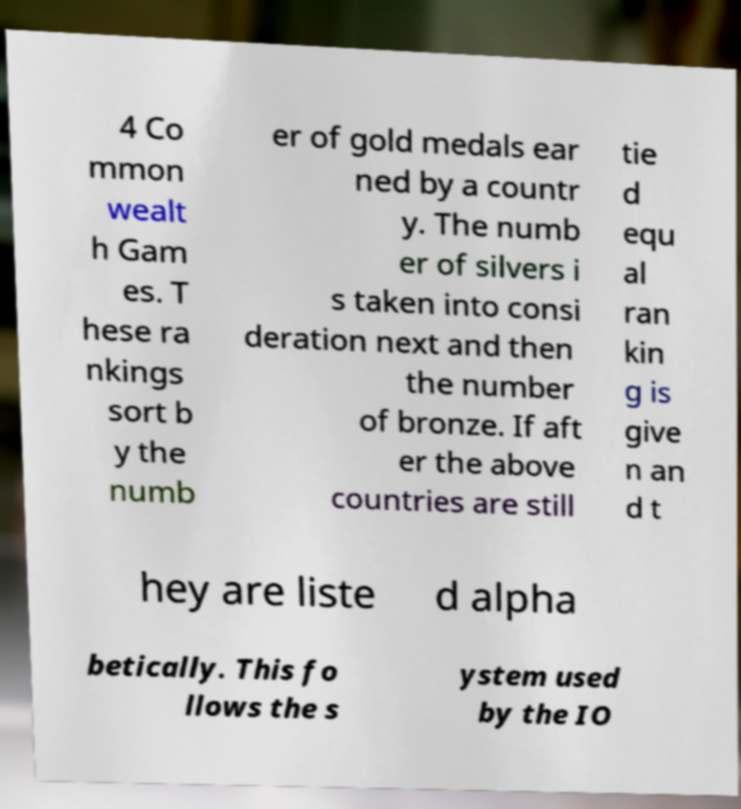Can you accurately transcribe the text from the provided image for me? 4 Co mmon wealt h Gam es. T hese ra nkings sort b y the numb er of gold medals ear ned by a countr y. The numb er of silvers i s taken into consi deration next and then the number of bronze. If aft er the above countries are still tie d equ al ran kin g is give n an d t hey are liste d alpha betically. This fo llows the s ystem used by the IO 